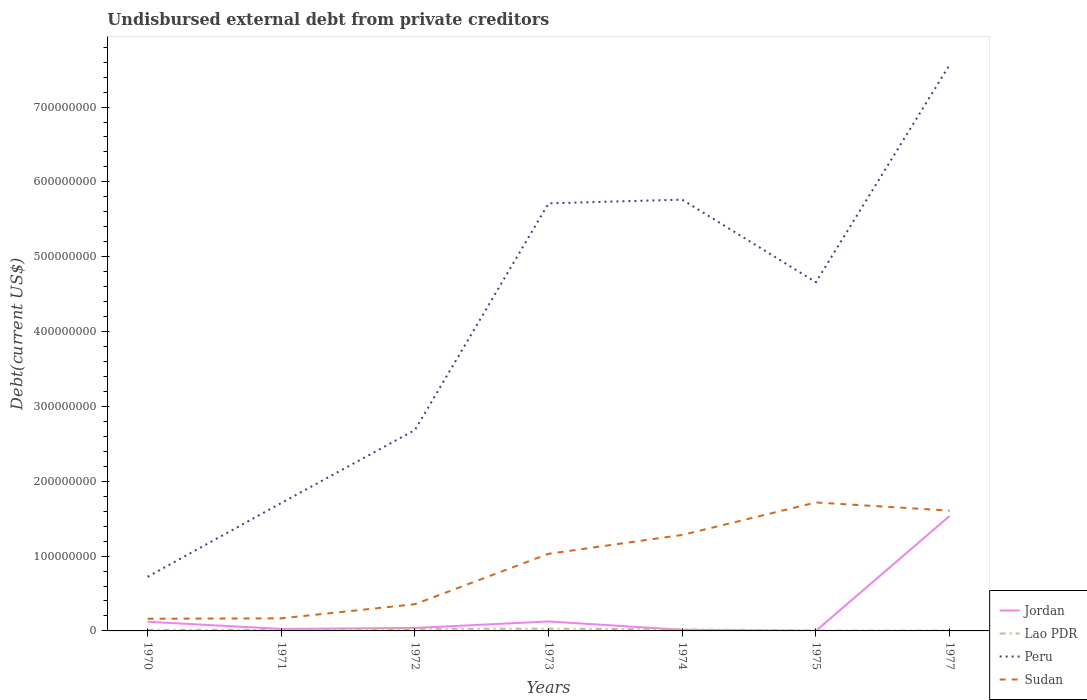How many different coloured lines are there?
Give a very brief answer. 4. Does the line corresponding to Jordan intersect with the line corresponding to Sudan?
Make the answer very short. No. Across all years, what is the maximum total debt in Sudan?
Ensure brevity in your answer.  1.63e+07. In which year was the total debt in Jordan maximum?
Keep it short and to the point. 1975. What is the total total debt in Peru in the graph?
Ensure brevity in your answer.  -6.84e+08. What is the difference between the highest and the second highest total debt in Lao PDR?
Your answer should be very brief. 2.59e+06. How many lines are there?
Offer a very short reply. 4. Where does the legend appear in the graph?
Your answer should be compact. Bottom right. How many legend labels are there?
Your response must be concise. 4. How are the legend labels stacked?
Provide a succinct answer. Vertical. What is the title of the graph?
Offer a very short reply. Undisbursed external debt from private creditors. Does "Japan" appear as one of the legend labels in the graph?
Make the answer very short. No. What is the label or title of the X-axis?
Give a very brief answer. Years. What is the label or title of the Y-axis?
Provide a short and direct response. Debt(current US$). What is the Debt(current US$) of Jordan in 1970?
Offer a terse response. 1.22e+07. What is the Debt(current US$) in Lao PDR in 1970?
Ensure brevity in your answer.  1.40e+06. What is the Debt(current US$) of Peru in 1970?
Keep it short and to the point. 7.23e+07. What is the Debt(current US$) of Sudan in 1970?
Offer a very short reply. 1.63e+07. What is the Debt(current US$) of Jordan in 1971?
Keep it short and to the point. 2.68e+06. What is the Debt(current US$) in Lao PDR in 1971?
Provide a succinct answer. 1.48e+06. What is the Debt(current US$) of Peru in 1971?
Offer a terse response. 1.71e+08. What is the Debt(current US$) of Sudan in 1971?
Offer a terse response. 1.68e+07. What is the Debt(current US$) in Jordan in 1972?
Offer a terse response. 3.98e+06. What is the Debt(current US$) of Lao PDR in 1972?
Provide a succinct answer. 2.75e+06. What is the Debt(current US$) in Peru in 1972?
Offer a terse response. 2.68e+08. What is the Debt(current US$) in Sudan in 1972?
Provide a short and direct response. 3.57e+07. What is the Debt(current US$) of Jordan in 1973?
Ensure brevity in your answer.  1.26e+07. What is the Debt(current US$) in Lao PDR in 1973?
Your answer should be compact. 3.04e+06. What is the Debt(current US$) in Peru in 1973?
Give a very brief answer. 5.71e+08. What is the Debt(current US$) of Sudan in 1973?
Give a very brief answer. 1.03e+08. What is the Debt(current US$) in Jordan in 1974?
Give a very brief answer. 1.51e+06. What is the Debt(current US$) of Lao PDR in 1974?
Your response must be concise. 2.06e+06. What is the Debt(current US$) of Peru in 1974?
Your answer should be very brief. 5.76e+08. What is the Debt(current US$) of Sudan in 1974?
Your response must be concise. 1.28e+08. What is the Debt(current US$) in Jordan in 1975?
Provide a short and direct response. 1.30e+04. What is the Debt(current US$) in Lao PDR in 1975?
Your answer should be compact. 5.19e+05. What is the Debt(current US$) in Peru in 1975?
Your response must be concise. 4.66e+08. What is the Debt(current US$) in Sudan in 1975?
Your response must be concise. 1.72e+08. What is the Debt(current US$) of Jordan in 1977?
Offer a terse response. 1.54e+08. What is the Debt(current US$) in Lao PDR in 1977?
Your answer should be very brief. 4.46e+05. What is the Debt(current US$) of Peru in 1977?
Your response must be concise. 7.56e+08. What is the Debt(current US$) of Sudan in 1977?
Offer a very short reply. 1.61e+08. Across all years, what is the maximum Debt(current US$) of Jordan?
Your answer should be compact. 1.54e+08. Across all years, what is the maximum Debt(current US$) in Lao PDR?
Offer a very short reply. 3.04e+06. Across all years, what is the maximum Debt(current US$) in Peru?
Provide a short and direct response. 7.56e+08. Across all years, what is the maximum Debt(current US$) in Sudan?
Provide a succinct answer. 1.72e+08. Across all years, what is the minimum Debt(current US$) of Jordan?
Provide a succinct answer. 1.30e+04. Across all years, what is the minimum Debt(current US$) in Lao PDR?
Make the answer very short. 4.46e+05. Across all years, what is the minimum Debt(current US$) in Peru?
Your response must be concise. 7.23e+07. Across all years, what is the minimum Debt(current US$) of Sudan?
Provide a short and direct response. 1.63e+07. What is the total Debt(current US$) in Jordan in the graph?
Your answer should be very brief. 1.87e+08. What is the total Debt(current US$) in Lao PDR in the graph?
Your answer should be very brief. 1.17e+07. What is the total Debt(current US$) in Peru in the graph?
Keep it short and to the point. 2.88e+09. What is the total Debt(current US$) in Sudan in the graph?
Your answer should be compact. 6.32e+08. What is the difference between the Debt(current US$) of Jordan in 1970 and that in 1971?
Make the answer very short. 9.56e+06. What is the difference between the Debt(current US$) of Lao PDR in 1970 and that in 1971?
Make the answer very short. -8.90e+04. What is the difference between the Debt(current US$) in Peru in 1970 and that in 1971?
Give a very brief answer. -9.86e+07. What is the difference between the Debt(current US$) in Sudan in 1970 and that in 1971?
Offer a very short reply. -5.22e+05. What is the difference between the Debt(current US$) in Jordan in 1970 and that in 1972?
Your response must be concise. 8.26e+06. What is the difference between the Debt(current US$) in Lao PDR in 1970 and that in 1972?
Ensure brevity in your answer.  -1.35e+06. What is the difference between the Debt(current US$) of Peru in 1970 and that in 1972?
Offer a terse response. -1.96e+08. What is the difference between the Debt(current US$) in Sudan in 1970 and that in 1972?
Make the answer very short. -1.94e+07. What is the difference between the Debt(current US$) of Jordan in 1970 and that in 1973?
Ensure brevity in your answer.  -3.90e+05. What is the difference between the Debt(current US$) of Lao PDR in 1970 and that in 1973?
Provide a short and direct response. -1.64e+06. What is the difference between the Debt(current US$) in Peru in 1970 and that in 1973?
Make the answer very short. -4.99e+08. What is the difference between the Debt(current US$) in Sudan in 1970 and that in 1973?
Keep it short and to the point. -8.68e+07. What is the difference between the Debt(current US$) in Jordan in 1970 and that in 1974?
Offer a terse response. 1.07e+07. What is the difference between the Debt(current US$) of Lao PDR in 1970 and that in 1974?
Your answer should be compact. -6.63e+05. What is the difference between the Debt(current US$) in Peru in 1970 and that in 1974?
Keep it short and to the point. -5.04e+08. What is the difference between the Debt(current US$) of Sudan in 1970 and that in 1974?
Provide a short and direct response. -1.12e+08. What is the difference between the Debt(current US$) in Jordan in 1970 and that in 1975?
Your answer should be compact. 1.22e+07. What is the difference between the Debt(current US$) of Lao PDR in 1970 and that in 1975?
Provide a succinct answer. 8.76e+05. What is the difference between the Debt(current US$) of Peru in 1970 and that in 1975?
Offer a terse response. -3.94e+08. What is the difference between the Debt(current US$) in Sudan in 1970 and that in 1975?
Provide a short and direct response. -1.55e+08. What is the difference between the Debt(current US$) in Jordan in 1970 and that in 1977?
Provide a succinct answer. -1.41e+08. What is the difference between the Debt(current US$) of Lao PDR in 1970 and that in 1977?
Provide a short and direct response. 9.49e+05. What is the difference between the Debt(current US$) in Peru in 1970 and that in 1977?
Ensure brevity in your answer.  -6.84e+08. What is the difference between the Debt(current US$) of Sudan in 1970 and that in 1977?
Your answer should be very brief. -1.44e+08. What is the difference between the Debt(current US$) of Jordan in 1971 and that in 1972?
Offer a terse response. -1.30e+06. What is the difference between the Debt(current US$) of Lao PDR in 1971 and that in 1972?
Ensure brevity in your answer.  -1.26e+06. What is the difference between the Debt(current US$) in Peru in 1971 and that in 1972?
Give a very brief answer. -9.75e+07. What is the difference between the Debt(current US$) of Sudan in 1971 and that in 1972?
Ensure brevity in your answer.  -1.89e+07. What is the difference between the Debt(current US$) in Jordan in 1971 and that in 1973?
Your response must be concise. -9.96e+06. What is the difference between the Debt(current US$) in Lao PDR in 1971 and that in 1973?
Ensure brevity in your answer.  -1.56e+06. What is the difference between the Debt(current US$) in Peru in 1971 and that in 1973?
Your response must be concise. -4.00e+08. What is the difference between the Debt(current US$) of Sudan in 1971 and that in 1973?
Ensure brevity in your answer.  -8.63e+07. What is the difference between the Debt(current US$) in Jordan in 1971 and that in 1974?
Provide a succinct answer. 1.17e+06. What is the difference between the Debt(current US$) in Lao PDR in 1971 and that in 1974?
Your answer should be very brief. -5.74e+05. What is the difference between the Debt(current US$) in Peru in 1971 and that in 1974?
Give a very brief answer. -4.05e+08. What is the difference between the Debt(current US$) in Sudan in 1971 and that in 1974?
Offer a very short reply. -1.11e+08. What is the difference between the Debt(current US$) in Jordan in 1971 and that in 1975?
Ensure brevity in your answer.  2.67e+06. What is the difference between the Debt(current US$) of Lao PDR in 1971 and that in 1975?
Your answer should be very brief. 9.65e+05. What is the difference between the Debt(current US$) of Peru in 1971 and that in 1975?
Your answer should be very brief. -2.95e+08. What is the difference between the Debt(current US$) in Sudan in 1971 and that in 1975?
Provide a short and direct response. -1.55e+08. What is the difference between the Debt(current US$) of Jordan in 1971 and that in 1977?
Ensure brevity in your answer.  -1.51e+08. What is the difference between the Debt(current US$) of Lao PDR in 1971 and that in 1977?
Offer a very short reply. 1.04e+06. What is the difference between the Debt(current US$) of Peru in 1971 and that in 1977?
Provide a short and direct response. -5.85e+08. What is the difference between the Debt(current US$) in Sudan in 1971 and that in 1977?
Make the answer very short. -1.44e+08. What is the difference between the Debt(current US$) in Jordan in 1972 and that in 1973?
Make the answer very short. -8.65e+06. What is the difference between the Debt(current US$) of Lao PDR in 1972 and that in 1973?
Your answer should be very brief. -2.92e+05. What is the difference between the Debt(current US$) of Peru in 1972 and that in 1973?
Make the answer very short. -3.03e+08. What is the difference between the Debt(current US$) in Sudan in 1972 and that in 1973?
Your answer should be very brief. -6.73e+07. What is the difference between the Debt(current US$) of Jordan in 1972 and that in 1974?
Make the answer very short. 2.47e+06. What is the difference between the Debt(current US$) in Lao PDR in 1972 and that in 1974?
Your response must be concise. 6.89e+05. What is the difference between the Debt(current US$) of Peru in 1972 and that in 1974?
Give a very brief answer. -3.08e+08. What is the difference between the Debt(current US$) in Sudan in 1972 and that in 1974?
Make the answer very short. -9.26e+07. What is the difference between the Debt(current US$) in Jordan in 1972 and that in 1975?
Give a very brief answer. 3.97e+06. What is the difference between the Debt(current US$) in Lao PDR in 1972 and that in 1975?
Provide a short and direct response. 2.23e+06. What is the difference between the Debt(current US$) in Peru in 1972 and that in 1975?
Give a very brief answer. -1.97e+08. What is the difference between the Debt(current US$) in Sudan in 1972 and that in 1975?
Keep it short and to the point. -1.36e+08. What is the difference between the Debt(current US$) of Jordan in 1972 and that in 1977?
Make the answer very short. -1.50e+08. What is the difference between the Debt(current US$) of Lao PDR in 1972 and that in 1977?
Offer a very short reply. 2.30e+06. What is the difference between the Debt(current US$) in Peru in 1972 and that in 1977?
Your answer should be very brief. -4.88e+08. What is the difference between the Debt(current US$) in Sudan in 1972 and that in 1977?
Your answer should be compact. -1.25e+08. What is the difference between the Debt(current US$) in Jordan in 1973 and that in 1974?
Give a very brief answer. 1.11e+07. What is the difference between the Debt(current US$) of Lao PDR in 1973 and that in 1974?
Offer a very short reply. 9.81e+05. What is the difference between the Debt(current US$) of Peru in 1973 and that in 1974?
Offer a very short reply. -4.98e+06. What is the difference between the Debt(current US$) in Sudan in 1973 and that in 1974?
Offer a terse response. -2.52e+07. What is the difference between the Debt(current US$) of Jordan in 1973 and that in 1975?
Make the answer very short. 1.26e+07. What is the difference between the Debt(current US$) of Lao PDR in 1973 and that in 1975?
Your answer should be very brief. 2.52e+06. What is the difference between the Debt(current US$) in Peru in 1973 and that in 1975?
Give a very brief answer. 1.05e+08. What is the difference between the Debt(current US$) of Sudan in 1973 and that in 1975?
Your response must be concise. -6.86e+07. What is the difference between the Debt(current US$) of Jordan in 1973 and that in 1977?
Your answer should be very brief. -1.41e+08. What is the difference between the Debt(current US$) in Lao PDR in 1973 and that in 1977?
Give a very brief answer. 2.59e+06. What is the difference between the Debt(current US$) of Peru in 1973 and that in 1977?
Make the answer very short. -1.85e+08. What is the difference between the Debt(current US$) of Sudan in 1973 and that in 1977?
Offer a terse response. -5.77e+07. What is the difference between the Debt(current US$) of Jordan in 1974 and that in 1975?
Your response must be concise. 1.50e+06. What is the difference between the Debt(current US$) in Lao PDR in 1974 and that in 1975?
Make the answer very short. 1.54e+06. What is the difference between the Debt(current US$) of Peru in 1974 and that in 1975?
Your answer should be very brief. 1.10e+08. What is the difference between the Debt(current US$) in Sudan in 1974 and that in 1975?
Make the answer very short. -4.34e+07. What is the difference between the Debt(current US$) of Jordan in 1974 and that in 1977?
Offer a very short reply. -1.52e+08. What is the difference between the Debt(current US$) of Lao PDR in 1974 and that in 1977?
Provide a succinct answer. 1.61e+06. What is the difference between the Debt(current US$) in Peru in 1974 and that in 1977?
Make the answer very short. -1.80e+08. What is the difference between the Debt(current US$) of Sudan in 1974 and that in 1977?
Give a very brief answer. -3.25e+07. What is the difference between the Debt(current US$) of Jordan in 1975 and that in 1977?
Offer a very short reply. -1.54e+08. What is the difference between the Debt(current US$) of Lao PDR in 1975 and that in 1977?
Your answer should be compact. 7.30e+04. What is the difference between the Debt(current US$) in Peru in 1975 and that in 1977?
Provide a short and direct response. -2.90e+08. What is the difference between the Debt(current US$) of Sudan in 1975 and that in 1977?
Make the answer very short. 1.09e+07. What is the difference between the Debt(current US$) of Jordan in 1970 and the Debt(current US$) of Lao PDR in 1971?
Make the answer very short. 1.08e+07. What is the difference between the Debt(current US$) in Jordan in 1970 and the Debt(current US$) in Peru in 1971?
Offer a very short reply. -1.59e+08. What is the difference between the Debt(current US$) in Jordan in 1970 and the Debt(current US$) in Sudan in 1971?
Your answer should be compact. -4.55e+06. What is the difference between the Debt(current US$) of Lao PDR in 1970 and the Debt(current US$) of Peru in 1971?
Provide a short and direct response. -1.70e+08. What is the difference between the Debt(current US$) of Lao PDR in 1970 and the Debt(current US$) of Sudan in 1971?
Give a very brief answer. -1.54e+07. What is the difference between the Debt(current US$) in Peru in 1970 and the Debt(current US$) in Sudan in 1971?
Provide a short and direct response. 5.55e+07. What is the difference between the Debt(current US$) in Jordan in 1970 and the Debt(current US$) in Lao PDR in 1972?
Provide a succinct answer. 9.50e+06. What is the difference between the Debt(current US$) in Jordan in 1970 and the Debt(current US$) in Peru in 1972?
Offer a very short reply. -2.56e+08. What is the difference between the Debt(current US$) of Jordan in 1970 and the Debt(current US$) of Sudan in 1972?
Offer a very short reply. -2.35e+07. What is the difference between the Debt(current US$) in Lao PDR in 1970 and the Debt(current US$) in Peru in 1972?
Keep it short and to the point. -2.67e+08. What is the difference between the Debt(current US$) of Lao PDR in 1970 and the Debt(current US$) of Sudan in 1972?
Provide a short and direct response. -3.43e+07. What is the difference between the Debt(current US$) in Peru in 1970 and the Debt(current US$) in Sudan in 1972?
Your answer should be compact. 3.66e+07. What is the difference between the Debt(current US$) in Jordan in 1970 and the Debt(current US$) in Lao PDR in 1973?
Keep it short and to the point. 9.21e+06. What is the difference between the Debt(current US$) of Jordan in 1970 and the Debt(current US$) of Peru in 1973?
Keep it short and to the point. -5.59e+08. What is the difference between the Debt(current US$) in Jordan in 1970 and the Debt(current US$) in Sudan in 1973?
Offer a terse response. -9.08e+07. What is the difference between the Debt(current US$) in Lao PDR in 1970 and the Debt(current US$) in Peru in 1973?
Your answer should be very brief. -5.70e+08. What is the difference between the Debt(current US$) of Lao PDR in 1970 and the Debt(current US$) of Sudan in 1973?
Keep it short and to the point. -1.02e+08. What is the difference between the Debt(current US$) in Peru in 1970 and the Debt(current US$) in Sudan in 1973?
Your answer should be compact. -3.07e+07. What is the difference between the Debt(current US$) of Jordan in 1970 and the Debt(current US$) of Lao PDR in 1974?
Ensure brevity in your answer.  1.02e+07. What is the difference between the Debt(current US$) of Jordan in 1970 and the Debt(current US$) of Peru in 1974?
Your answer should be compact. -5.64e+08. What is the difference between the Debt(current US$) of Jordan in 1970 and the Debt(current US$) of Sudan in 1974?
Keep it short and to the point. -1.16e+08. What is the difference between the Debt(current US$) of Lao PDR in 1970 and the Debt(current US$) of Peru in 1974?
Make the answer very short. -5.75e+08. What is the difference between the Debt(current US$) of Lao PDR in 1970 and the Debt(current US$) of Sudan in 1974?
Ensure brevity in your answer.  -1.27e+08. What is the difference between the Debt(current US$) in Peru in 1970 and the Debt(current US$) in Sudan in 1974?
Give a very brief answer. -5.60e+07. What is the difference between the Debt(current US$) of Jordan in 1970 and the Debt(current US$) of Lao PDR in 1975?
Offer a very short reply. 1.17e+07. What is the difference between the Debt(current US$) in Jordan in 1970 and the Debt(current US$) in Peru in 1975?
Keep it short and to the point. -4.54e+08. What is the difference between the Debt(current US$) in Jordan in 1970 and the Debt(current US$) in Sudan in 1975?
Give a very brief answer. -1.59e+08. What is the difference between the Debt(current US$) in Lao PDR in 1970 and the Debt(current US$) in Peru in 1975?
Your answer should be very brief. -4.65e+08. What is the difference between the Debt(current US$) of Lao PDR in 1970 and the Debt(current US$) of Sudan in 1975?
Your answer should be very brief. -1.70e+08. What is the difference between the Debt(current US$) of Peru in 1970 and the Debt(current US$) of Sudan in 1975?
Keep it short and to the point. -9.94e+07. What is the difference between the Debt(current US$) of Jordan in 1970 and the Debt(current US$) of Lao PDR in 1977?
Provide a succinct answer. 1.18e+07. What is the difference between the Debt(current US$) in Jordan in 1970 and the Debt(current US$) in Peru in 1977?
Your answer should be compact. -7.44e+08. What is the difference between the Debt(current US$) of Jordan in 1970 and the Debt(current US$) of Sudan in 1977?
Your answer should be compact. -1.48e+08. What is the difference between the Debt(current US$) in Lao PDR in 1970 and the Debt(current US$) in Peru in 1977?
Offer a terse response. -7.55e+08. What is the difference between the Debt(current US$) of Lao PDR in 1970 and the Debt(current US$) of Sudan in 1977?
Offer a terse response. -1.59e+08. What is the difference between the Debt(current US$) of Peru in 1970 and the Debt(current US$) of Sudan in 1977?
Your response must be concise. -8.84e+07. What is the difference between the Debt(current US$) of Jordan in 1971 and the Debt(current US$) of Lao PDR in 1972?
Your answer should be compact. -6.50e+04. What is the difference between the Debt(current US$) in Jordan in 1971 and the Debt(current US$) in Peru in 1972?
Your answer should be very brief. -2.66e+08. What is the difference between the Debt(current US$) of Jordan in 1971 and the Debt(current US$) of Sudan in 1972?
Provide a short and direct response. -3.30e+07. What is the difference between the Debt(current US$) in Lao PDR in 1971 and the Debt(current US$) in Peru in 1972?
Your answer should be very brief. -2.67e+08. What is the difference between the Debt(current US$) in Lao PDR in 1971 and the Debt(current US$) in Sudan in 1972?
Give a very brief answer. -3.42e+07. What is the difference between the Debt(current US$) in Peru in 1971 and the Debt(current US$) in Sudan in 1972?
Make the answer very short. 1.35e+08. What is the difference between the Debt(current US$) in Jordan in 1971 and the Debt(current US$) in Lao PDR in 1973?
Provide a short and direct response. -3.57e+05. What is the difference between the Debt(current US$) of Jordan in 1971 and the Debt(current US$) of Peru in 1973?
Your answer should be compact. -5.69e+08. What is the difference between the Debt(current US$) of Jordan in 1971 and the Debt(current US$) of Sudan in 1973?
Your answer should be compact. -1.00e+08. What is the difference between the Debt(current US$) in Lao PDR in 1971 and the Debt(current US$) in Peru in 1973?
Offer a terse response. -5.70e+08. What is the difference between the Debt(current US$) of Lao PDR in 1971 and the Debt(current US$) of Sudan in 1973?
Your response must be concise. -1.02e+08. What is the difference between the Debt(current US$) in Peru in 1971 and the Debt(current US$) in Sudan in 1973?
Provide a short and direct response. 6.79e+07. What is the difference between the Debt(current US$) in Jordan in 1971 and the Debt(current US$) in Lao PDR in 1974?
Your response must be concise. 6.24e+05. What is the difference between the Debt(current US$) of Jordan in 1971 and the Debt(current US$) of Peru in 1974?
Keep it short and to the point. -5.74e+08. What is the difference between the Debt(current US$) in Jordan in 1971 and the Debt(current US$) in Sudan in 1974?
Your answer should be compact. -1.26e+08. What is the difference between the Debt(current US$) in Lao PDR in 1971 and the Debt(current US$) in Peru in 1974?
Offer a very short reply. -5.75e+08. What is the difference between the Debt(current US$) of Lao PDR in 1971 and the Debt(current US$) of Sudan in 1974?
Your response must be concise. -1.27e+08. What is the difference between the Debt(current US$) in Peru in 1971 and the Debt(current US$) in Sudan in 1974?
Your answer should be compact. 4.27e+07. What is the difference between the Debt(current US$) of Jordan in 1971 and the Debt(current US$) of Lao PDR in 1975?
Offer a terse response. 2.16e+06. What is the difference between the Debt(current US$) in Jordan in 1971 and the Debt(current US$) in Peru in 1975?
Keep it short and to the point. -4.63e+08. What is the difference between the Debt(current US$) in Jordan in 1971 and the Debt(current US$) in Sudan in 1975?
Provide a succinct answer. -1.69e+08. What is the difference between the Debt(current US$) in Lao PDR in 1971 and the Debt(current US$) in Peru in 1975?
Your answer should be compact. -4.64e+08. What is the difference between the Debt(current US$) in Lao PDR in 1971 and the Debt(current US$) in Sudan in 1975?
Offer a terse response. -1.70e+08. What is the difference between the Debt(current US$) of Peru in 1971 and the Debt(current US$) of Sudan in 1975?
Make the answer very short. -7.37e+05. What is the difference between the Debt(current US$) of Jordan in 1971 and the Debt(current US$) of Lao PDR in 1977?
Your answer should be compact. 2.24e+06. What is the difference between the Debt(current US$) in Jordan in 1971 and the Debt(current US$) in Peru in 1977?
Make the answer very short. -7.54e+08. What is the difference between the Debt(current US$) of Jordan in 1971 and the Debt(current US$) of Sudan in 1977?
Provide a succinct answer. -1.58e+08. What is the difference between the Debt(current US$) in Lao PDR in 1971 and the Debt(current US$) in Peru in 1977?
Make the answer very short. -7.55e+08. What is the difference between the Debt(current US$) of Lao PDR in 1971 and the Debt(current US$) of Sudan in 1977?
Offer a very short reply. -1.59e+08. What is the difference between the Debt(current US$) in Peru in 1971 and the Debt(current US$) in Sudan in 1977?
Your answer should be very brief. 1.02e+07. What is the difference between the Debt(current US$) in Jordan in 1972 and the Debt(current US$) in Lao PDR in 1973?
Your response must be concise. 9.44e+05. What is the difference between the Debt(current US$) in Jordan in 1972 and the Debt(current US$) in Peru in 1973?
Offer a terse response. -5.67e+08. What is the difference between the Debt(current US$) of Jordan in 1972 and the Debt(current US$) of Sudan in 1973?
Provide a succinct answer. -9.91e+07. What is the difference between the Debt(current US$) in Lao PDR in 1972 and the Debt(current US$) in Peru in 1973?
Make the answer very short. -5.69e+08. What is the difference between the Debt(current US$) of Lao PDR in 1972 and the Debt(current US$) of Sudan in 1973?
Your answer should be compact. -1.00e+08. What is the difference between the Debt(current US$) in Peru in 1972 and the Debt(current US$) in Sudan in 1973?
Your answer should be compact. 1.65e+08. What is the difference between the Debt(current US$) of Jordan in 1972 and the Debt(current US$) of Lao PDR in 1974?
Your answer should be compact. 1.92e+06. What is the difference between the Debt(current US$) in Jordan in 1972 and the Debt(current US$) in Peru in 1974?
Make the answer very short. -5.72e+08. What is the difference between the Debt(current US$) of Jordan in 1972 and the Debt(current US$) of Sudan in 1974?
Keep it short and to the point. -1.24e+08. What is the difference between the Debt(current US$) in Lao PDR in 1972 and the Debt(current US$) in Peru in 1974?
Ensure brevity in your answer.  -5.74e+08. What is the difference between the Debt(current US$) in Lao PDR in 1972 and the Debt(current US$) in Sudan in 1974?
Provide a short and direct response. -1.26e+08. What is the difference between the Debt(current US$) in Peru in 1972 and the Debt(current US$) in Sudan in 1974?
Make the answer very short. 1.40e+08. What is the difference between the Debt(current US$) in Jordan in 1972 and the Debt(current US$) in Lao PDR in 1975?
Offer a very short reply. 3.46e+06. What is the difference between the Debt(current US$) of Jordan in 1972 and the Debt(current US$) of Peru in 1975?
Your answer should be very brief. -4.62e+08. What is the difference between the Debt(current US$) in Jordan in 1972 and the Debt(current US$) in Sudan in 1975?
Keep it short and to the point. -1.68e+08. What is the difference between the Debt(current US$) in Lao PDR in 1972 and the Debt(current US$) in Peru in 1975?
Ensure brevity in your answer.  -4.63e+08. What is the difference between the Debt(current US$) in Lao PDR in 1972 and the Debt(current US$) in Sudan in 1975?
Offer a very short reply. -1.69e+08. What is the difference between the Debt(current US$) in Peru in 1972 and the Debt(current US$) in Sudan in 1975?
Give a very brief answer. 9.68e+07. What is the difference between the Debt(current US$) in Jordan in 1972 and the Debt(current US$) in Lao PDR in 1977?
Offer a terse response. 3.54e+06. What is the difference between the Debt(current US$) of Jordan in 1972 and the Debt(current US$) of Peru in 1977?
Make the answer very short. -7.52e+08. What is the difference between the Debt(current US$) of Jordan in 1972 and the Debt(current US$) of Sudan in 1977?
Your answer should be compact. -1.57e+08. What is the difference between the Debt(current US$) in Lao PDR in 1972 and the Debt(current US$) in Peru in 1977?
Your answer should be compact. -7.54e+08. What is the difference between the Debt(current US$) in Lao PDR in 1972 and the Debt(current US$) in Sudan in 1977?
Provide a short and direct response. -1.58e+08. What is the difference between the Debt(current US$) in Peru in 1972 and the Debt(current US$) in Sudan in 1977?
Ensure brevity in your answer.  1.08e+08. What is the difference between the Debt(current US$) in Jordan in 1973 and the Debt(current US$) in Lao PDR in 1974?
Make the answer very short. 1.06e+07. What is the difference between the Debt(current US$) in Jordan in 1973 and the Debt(current US$) in Peru in 1974?
Give a very brief answer. -5.64e+08. What is the difference between the Debt(current US$) in Jordan in 1973 and the Debt(current US$) in Sudan in 1974?
Your response must be concise. -1.16e+08. What is the difference between the Debt(current US$) of Lao PDR in 1973 and the Debt(current US$) of Peru in 1974?
Provide a short and direct response. -5.73e+08. What is the difference between the Debt(current US$) in Lao PDR in 1973 and the Debt(current US$) in Sudan in 1974?
Offer a terse response. -1.25e+08. What is the difference between the Debt(current US$) of Peru in 1973 and the Debt(current US$) of Sudan in 1974?
Offer a terse response. 4.43e+08. What is the difference between the Debt(current US$) of Jordan in 1973 and the Debt(current US$) of Lao PDR in 1975?
Give a very brief answer. 1.21e+07. What is the difference between the Debt(current US$) in Jordan in 1973 and the Debt(current US$) in Peru in 1975?
Give a very brief answer. -4.53e+08. What is the difference between the Debt(current US$) of Jordan in 1973 and the Debt(current US$) of Sudan in 1975?
Provide a short and direct response. -1.59e+08. What is the difference between the Debt(current US$) in Lao PDR in 1973 and the Debt(current US$) in Peru in 1975?
Provide a short and direct response. -4.63e+08. What is the difference between the Debt(current US$) of Lao PDR in 1973 and the Debt(current US$) of Sudan in 1975?
Offer a terse response. -1.69e+08. What is the difference between the Debt(current US$) of Peru in 1973 and the Debt(current US$) of Sudan in 1975?
Offer a very short reply. 4.00e+08. What is the difference between the Debt(current US$) in Jordan in 1973 and the Debt(current US$) in Lao PDR in 1977?
Provide a succinct answer. 1.22e+07. What is the difference between the Debt(current US$) in Jordan in 1973 and the Debt(current US$) in Peru in 1977?
Give a very brief answer. -7.44e+08. What is the difference between the Debt(current US$) of Jordan in 1973 and the Debt(current US$) of Sudan in 1977?
Give a very brief answer. -1.48e+08. What is the difference between the Debt(current US$) in Lao PDR in 1973 and the Debt(current US$) in Peru in 1977?
Ensure brevity in your answer.  -7.53e+08. What is the difference between the Debt(current US$) of Lao PDR in 1973 and the Debt(current US$) of Sudan in 1977?
Offer a very short reply. -1.58e+08. What is the difference between the Debt(current US$) in Peru in 1973 and the Debt(current US$) in Sudan in 1977?
Ensure brevity in your answer.  4.11e+08. What is the difference between the Debt(current US$) of Jordan in 1974 and the Debt(current US$) of Lao PDR in 1975?
Provide a succinct answer. 9.92e+05. What is the difference between the Debt(current US$) in Jordan in 1974 and the Debt(current US$) in Peru in 1975?
Provide a succinct answer. -4.64e+08. What is the difference between the Debt(current US$) in Jordan in 1974 and the Debt(current US$) in Sudan in 1975?
Provide a short and direct response. -1.70e+08. What is the difference between the Debt(current US$) in Lao PDR in 1974 and the Debt(current US$) in Peru in 1975?
Give a very brief answer. -4.64e+08. What is the difference between the Debt(current US$) in Lao PDR in 1974 and the Debt(current US$) in Sudan in 1975?
Offer a very short reply. -1.70e+08. What is the difference between the Debt(current US$) in Peru in 1974 and the Debt(current US$) in Sudan in 1975?
Your response must be concise. 4.05e+08. What is the difference between the Debt(current US$) in Jordan in 1974 and the Debt(current US$) in Lao PDR in 1977?
Make the answer very short. 1.06e+06. What is the difference between the Debt(current US$) of Jordan in 1974 and the Debt(current US$) of Peru in 1977?
Make the answer very short. -7.55e+08. What is the difference between the Debt(current US$) of Jordan in 1974 and the Debt(current US$) of Sudan in 1977?
Your answer should be very brief. -1.59e+08. What is the difference between the Debt(current US$) in Lao PDR in 1974 and the Debt(current US$) in Peru in 1977?
Offer a very short reply. -7.54e+08. What is the difference between the Debt(current US$) of Lao PDR in 1974 and the Debt(current US$) of Sudan in 1977?
Provide a short and direct response. -1.59e+08. What is the difference between the Debt(current US$) in Peru in 1974 and the Debt(current US$) in Sudan in 1977?
Make the answer very short. 4.16e+08. What is the difference between the Debt(current US$) of Jordan in 1975 and the Debt(current US$) of Lao PDR in 1977?
Ensure brevity in your answer.  -4.33e+05. What is the difference between the Debt(current US$) in Jordan in 1975 and the Debt(current US$) in Peru in 1977?
Give a very brief answer. -7.56e+08. What is the difference between the Debt(current US$) in Jordan in 1975 and the Debt(current US$) in Sudan in 1977?
Provide a short and direct response. -1.61e+08. What is the difference between the Debt(current US$) of Lao PDR in 1975 and the Debt(current US$) of Peru in 1977?
Provide a succinct answer. -7.56e+08. What is the difference between the Debt(current US$) in Lao PDR in 1975 and the Debt(current US$) in Sudan in 1977?
Your answer should be very brief. -1.60e+08. What is the difference between the Debt(current US$) in Peru in 1975 and the Debt(current US$) in Sudan in 1977?
Give a very brief answer. 3.05e+08. What is the average Debt(current US$) of Jordan per year?
Provide a succinct answer. 2.67e+07. What is the average Debt(current US$) of Lao PDR per year?
Offer a terse response. 1.67e+06. What is the average Debt(current US$) of Peru per year?
Make the answer very short. 4.12e+08. What is the average Debt(current US$) in Sudan per year?
Your answer should be very brief. 9.04e+07. In the year 1970, what is the difference between the Debt(current US$) of Jordan and Debt(current US$) of Lao PDR?
Offer a terse response. 1.09e+07. In the year 1970, what is the difference between the Debt(current US$) of Jordan and Debt(current US$) of Peru?
Your answer should be very brief. -6.01e+07. In the year 1970, what is the difference between the Debt(current US$) of Jordan and Debt(current US$) of Sudan?
Offer a terse response. -4.02e+06. In the year 1970, what is the difference between the Debt(current US$) of Lao PDR and Debt(current US$) of Peru?
Provide a short and direct response. -7.09e+07. In the year 1970, what is the difference between the Debt(current US$) in Lao PDR and Debt(current US$) in Sudan?
Offer a terse response. -1.49e+07. In the year 1970, what is the difference between the Debt(current US$) of Peru and Debt(current US$) of Sudan?
Keep it short and to the point. 5.60e+07. In the year 1971, what is the difference between the Debt(current US$) of Jordan and Debt(current US$) of Lao PDR?
Your answer should be very brief. 1.20e+06. In the year 1971, what is the difference between the Debt(current US$) of Jordan and Debt(current US$) of Peru?
Your response must be concise. -1.68e+08. In the year 1971, what is the difference between the Debt(current US$) in Jordan and Debt(current US$) in Sudan?
Make the answer very short. -1.41e+07. In the year 1971, what is the difference between the Debt(current US$) in Lao PDR and Debt(current US$) in Peru?
Ensure brevity in your answer.  -1.69e+08. In the year 1971, what is the difference between the Debt(current US$) in Lao PDR and Debt(current US$) in Sudan?
Provide a short and direct response. -1.53e+07. In the year 1971, what is the difference between the Debt(current US$) of Peru and Debt(current US$) of Sudan?
Provide a short and direct response. 1.54e+08. In the year 1972, what is the difference between the Debt(current US$) in Jordan and Debt(current US$) in Lao PDR?
Make the answer very short. 1.24e+06. In the year 1972, what is the difference between the Debt(current US$) in Jordan and Debt(current US$) in Peru?
Your answer should be very brief. -2.64e+08. In the year 1972, what is the difference between the Debt(current US$) in Jordan and Debt(current US$) in Sudan?
Ensure brevity in your answer.  -3.17e+07. In the year 1972, what is the difference between the Debt(current US$) in Lao PDR and Debt(current US$) in Peru?
Your answer should be very brief. -2.66e+08. In the year 1972, what is the difference between the Debt(current US$) of Lao PDR and Debt(current US$) of Sudan?
Provide a short and direct response. -3.30e+07. In the year 1972, what is the difference between the Debt(current US$) of Peru and Debt(current US$) of Sudan?
Provide a short and direct response. 2.33e+08. In the year 1973, what is the difference between the Debt(current US$) of Jordan and Debt(current US$) of Lao PDR?
Provide a succinct answer. 9.60e+06. In the year 1973, what is the difference between the Debt(current US$) in Jordan and Debt(current US$) in Peru?
Provide a short and direct response. -5.59e+08. In the year 1973, what is the difference between the Debt(current US$) in Jordan and Debt(current US$) in Sudan?
Your answer should be compact. -9.04e+07. In the year 1973, what is the difference between the Debt(current US$) in Lao PDR and Debt(current US$) in Peru?
Offer a terse response. -5.68e+08. In the year 1973, what is the difference between the Debt(current US$) of Lao PDR and Debt(current US$) of Sudan?
Provide a succinct answer. -1.00e+08. In the year 1973, what is the difference between the Debt(current US$) in Peru and Debt(current US$) in Sudan?
Your answer should be very brief. 4.68e+08. In the year 1974, what is the difference between the Debt(current US$) in Jordan and Debt(current US$) in Lao PDR?
Offer a very short reply. -5.47e+05. In the year 1974, what is the difference between the Debt(current US$) of Jordan and Debt(current US$) of Peru?
Your answer should be compact. -5.75e+08. In the year 1974, what is the difference between the Debt(current US$) in Jordan and Debt(current US$) in Sudan?
Provide a succinct answer. -1.27e+08. In the year 1974, what is the difference between the Debt(current US$) of Lao PDR and Debt(current US$) of Peru?
Give a very brief answer. -5.74e+08. In the year 1974, what is the difference between the Debt(current US$) in Lao PDR and Debt(current US$) in Sudan?
Offer a terse response. -1.26e+08. In the year 1974, what is the difference between the Debt(current US$) in Peru and Debt(current US$) in Sudan?
Make the answer very short. 4.48e+08. In the year 1975, what is the difference between the Debt(current US$) of Jordan and Debt(current US$) of Lao PDR?
Make the answer very short. -5.06e+05. In the year 1975, what is the difference between the Debt(current US$) in Jordan and Debt(current US$) in Peru?
Your answer should be very brief. -4.66e+08. In the year 1975, what is the difference between the Debt(current US$) of Jordan and Debt(current US$) of Sudan?
Your response must be concise. -1.72e+08. In the year 1975, what is the difference between the Debt(current US$) in Lao PDR and Debt(current US$) in Peru?
Offer a very short reply. -4.65e+08. In the year 1975, what is the difference between the Debt(current US$) in Lao PDR and Debt(current US$) in Sudan?
Offer a very short reply. -1.71e+08. In the year 1975, what is the difference between the Debt(current US$) of Peru and Debt(current US$) of Sudan?
Make the answer very short. 2.94e+08. In the year 1977, what is the difference between the Debt(current US$) in Jordan and Debt(current US$) in Lao PDR?
Give a very brief answer. 1.53e+08. In the year 1977, what is the difference between the Debt(current US$) of Jordan and Debt(current US$) of Peru?
Provide a succinct answer. -6.03e+08. In the year 1977, what is the difference between the Debt(current US$) in Jordan and Debt(current US$) in Sudan?
Ensure brevity in your answer.  -7.17e+06. In the year 1977, what is the difference between the Debt(current US$) in Lao PDR and Debt(current US$) in Peru?
Make the answer very short. -7.56e+08. In the year 1977, what is the difference between the Debt(current US$) in Lao PDR and Debt(current US$) in Sudan?
Keep it short and to the point. -1.60e+08. In the year 1977, what is the difference between the Debt(current US$) in Peru and Debt(current US$) in Sudan?
Provide a succinct answer. 5.96e+08. What is the ratio of the Debt(current US$) of Jordan in 1970 to that in 1971?
Ensure brevity in your answer.  4.57. What is the ratio of the Debt(current US$) of Lao PDR in 1970 to that in 1971?
Provide a short and direct response. 0.94. What is the ratio of the Debt(current US$) in Peru in 1970 to that in 1971?
Your answer should be compact. 0.42. What is the ratio of the Debt(current US$) in Sudan in 1970 to that in 1971?
Your answer should be very brief. 0.97. What is the ratio of the Debt(current US$) in Jordan in 1970 to that in 1972?
Your response must be concise. 3.07. What is the ratio of the Debt(current US$) of Lao PDR in 1970 to that in 1972?
Your answer should be compact. 0.51. What is the ratio of the Debt(current US$) in Peru in 1970 to that in 1972?
Your response must be concise. 0.27. What is the ratio of the Debt(current US$) of Sudan in 1970 to that in 1972?
Your response must be concise. 0.46. What is the ratio of the Debt(current US$) of Jordan in 1970 to that in 1973?
Keep it short and to the point. 0.97. What is the ratio of the Debt(current US$) of Lao PDR in 1970 to that in 1973?
Make the answer very short. 0.46. What is the ratio of the Debt(current US$) of Peru in 1970 to that in 1973?
Give a very brief answer. 0.13. What is the ratio of the Debt(current US$) in Sudan in 1970 to that in 1973?
Provide a short and direct response. 0.16. What is the ratio of the Debt(current US$) in Jordan in 1970 to that in 1974?
Your response must be concise. 8.11. What is the ratio of the Debt(current US$) of Lao PDR in 1970 to that in 1974?
Ensure brevity in your answer.  0.68. What is the ratio of the Debt(current US$) in Peru in 1970 to that in 1974?
Your answer should be compact. 0.13. What is the ratio of the Debt(current US$) of Sudan in 1970 to that in 1974?
Provide a short and direct response. 0.13. What is the ratio of the Debt(current US$) of Jordan in 1970 to that in 1975?
Give a very brief answer. 942.08. What is the ratio of the Debt(current US$) in Lao PDR in 1970 to that in 1975?
Keep it short and to the point. 2.69. What is the ratio of the Debt(current US$) in Peru in 1970 to that in 1975?
Make the answer very short. 0.16. What is the ratio of the Debt(current US$) in Sudan in 1970 to that in 1975?
Provide a succinct answer. 0.09. What is the ratio of the Debt(current US$) of Jordan in 1970 to that in 1977?
Make the answer very short. 0.08. What is the ratio of the Debt(current US$) of Lao PDR in 1970 to that in 1977?
Give a very brief answer. 3.13. What is the ratio of the Debt(current US$) of Peru in 1970 to that in 1977?
Give a very brief answer. 0.1. What is the ratio of the Debt(current US$) in Sudan in 1970 to that in 1977?
Offer a very short reply. 0.1. What is the ratio of the Debt(current US$) of Jordan in 1971 to that in 1972?
Ensure brevity in your answer.  0.67. What is the ratio of the Debt(current US$) in Lao PDR in 1971 to that in 1972?
Your answer should be very brief. 0.54. What is the ratio of the Debt(current US$) of Peru in 1971 to that in 1972?
Ensure brevity in your answer.  0.64. What is the ratio of the Debt(current US$) of Sudan in 1971 to that in 1972?
Give a very brief answer. 0.47. What is the ratio of the Debt(current US$) in Jordan in 1971 to that in 1973?
Offer a terse response. 0.21. What is the ratio of the Debt(current US$) of Lao PDR in 1971 to that in 1973?
Your answer should be compact. 0.49. What is the ratio of the Debt(current US$) of Peru in 1971 to that in 1973?
Keep it short and to the point. 0.3. What is the ratio of the Debt(current US$) of Sudan in 1971 to that in 1973?
Your response must be concise. 0.16. What is the ratio of the Debt(current US$) in Jordan in 1971 to that in 1974?
Offer a very short reply. 1.77. What is the ratio of the Debt(current US$) of Lao PDR in 1971 to that in 1974?
Offer a very short reply. 0.72. What is the ratio of the Debt(current US$) of Peru in 1971 to that in 1974?
Offer a terse response. 0.3. What is the ratio of the Debt(current US$) of Sudan in 1971 to that in 1974?
Your answer should be very brief. 0.13. What is the ratio of the Debt(current US$) of Jordan in 1971 to that in 1975?
Offer a very short reply. 206.31. What is the ratio of the Debt(current US$) of Lao PDR in 1971 to that in 1975?
Offer a very short reply. 2.86. What is the ratio of the Debt(current US$) in Peru in 1971 to that in 1975?
Provide a short and direct response. 0.37. What is the ratio of the Debt(current US$) of Sudan in 1971 to that in 1975?
Your response must be concise. 0.1. What is the ratio of the Debt(current US$) of Jordan in 1971 to that in 1977?
Keep it short and to the point. 0.02. What is the ratio of the Debt(current US$) in Lao PDR in 1971 to that in 1977?
Provide a succinct answer. 3.33. What is the ratio of the Debt(current US$) in Peru in 1971 to that in 1977?
Your answer should be very brief. 0.23. What is the ratio of the Debt(current US$) in Sudan in 1971 to that in 1977?
Offer a very short reply. 0.1. What is the ratio of the Debt(current US$) of Jordan in 1972 to that in 1973?
Keep it short and to the point. 0.32. What is the ratio of the Debt(current US$) of Lao PDR in 1972 to that in 1973?
Your response must be concise. 0.9. What is the ratio of the Debt(current US$) in Peru in 1972 to that in 1973?
Offer a terse response. 0.47. What is the ratio of the Debt(current US$) of Sudan in 1972 to that in 1973?
Your answer should be very brief. 0.35. What is the ratio of the Debt(current US$) in Jordan in 1972 to that in 1974?
Offer a very short reply. 2.64. What is the ratio of the Debt(current US$) in Lao PDR in 1972 to that in 1974?
Keep it short and to the point. 1.33. What is the ratio of the Debt(current US$) of Peru in 1972 to that in 1974?
Provide a succinct answer. 0.47. What is the ratio of the Debt(current US$) in Sudan in 1972 to that in 1974?
Your answer should be very brief. 0.28. What is the ratio of the Debt(current US$) in Jordan in 1972 to that in 1975?
Your response must be concise. 306.38. What is the ratio of the Debt(current US$) in Lao PDR in 1972 to that in 1975?
Provide a short and direct response. 5.29. What is the ratio of the Debt(current US$) in Peru in 1972 to that in 1975?
Offer a terse response. 0.58. What is the ratio of the Debt(current US$) of Sudan in 1972 to that in 1975?
Give a very brief answer. 0.21. What is the ratio of the Debt(current US$) of Jordan in 1972 to that in 1977?
Provide a succinct answer. 0.03. What is the ratio of the Debt(current US$) of Lao PDR in 1972 to that in 1977?
Make the answer very short. 6.16. What is the ratio of the Debt(current US$) in Peru in 1972 to that in 1977?
Provide a succinct answer. 0.35. What is the ratio of the Debt(current US$) in Sudan in 1972 to that in 1977?
Your answer should be compact. 0.22. What is the ratio of the Debt(current US$) in Jordan in 1973 to that in 1974?
Make the answer very short. 8.36. What is the ratio of the Debt(current US$) of Lao PDR in 1973 to that in 1974?
Offer a terse response. 1.48. What is the ratio of the Debt(current US$) of Sudan in 1973 to that in 1974?
Your answer should be compact. 0.8. What is the ratio of the Debt(current US$) in Jordan in 1973 to that in 1975?
Provide a succinct answer. 972.08. What is the ratio of the Debt(current US$) of Lao PDR in 1973 to that in 1975?
Provide a short and direct response. 5.86. What is the ratio of the Debt(current US$) of Peru in 1973 to that in 1975?
Provide a succinct answer. 1.23. What is the ratio of the Debt(current US$) of Sudan in 1973 to that in 1975?
Your answer should be compact. 0.6. What is the ratio of the Debt(current US$) of Jordan in 1973 to that in 1977?
Give a very brief answer. 0.08. What is the ratio of the Debt(current US$) of Lao PDR in 1973 to that in 1977?
Give a very brief answer. 6.81. What is the ratio of the Debt(current US$) in Peru in 1973 to that in 1977?
Ensure brevity in your answer.  0.76. What is the ratio of the Debt(current US$) of Sudan in 1973 to that in 1977?
Your answer should be compact. 0.64. What is the ratio of the Debt(current US$) in Jordan in 1974 to that in 1975?
Offer a terse response. 116.23. What is the ratio of the Debt(current US$) in Lao PDR in 1974 to that in 1975?
Give a very brief answer. 3.97. What is the ratio of the Debt(current US$) in Peru in 1974 to that in 1975?
Your answer should be very brief. 1.24. What is the ratio of the Debt(current US$) in Sudan in 1974 to that in 1975?
Offer a terse response. 0.75. What is the ratio of the Debt(current US$) of Jordan in 1974 to that in 1977?
Offer a very short reply. 0.01. What is the ratio of the Debt(current US$) of Lao PDR in 1974 to that in 1977?
Your answer should be compact. 4.61. What is the ratio of the Debt(current US$) of Peru in 1974 to that in 1977?
Offer a very short reply. 0.76. What is the ratio of the Debt(current US$) of Sudan in 1974 to that in 1977?
Your answer should be very brief. 0.8. What is the ratio of the Debt(current US$) of Lao PDR in 1975 to that in 1977?
Your answer should be very brief. 1.16. What is the ratio of the Debt(current US$) in Peru in 1975 to that in 1977?
Keep it short and to the point. 0.62. What is the ratio of the Debt(current US$) of Sudan in 1975 to that in 1977?
Keep it short and to the point. 1.07. What is the difference between the highest and the second highest Debt(current US$) of Jordan?
Make the answer very short. 1.41e+08. What is the difference between the highest and the second highest Debt(current US$) in Lao PDR?
Give a very brief answer. 2.92e+05. What is the difference between the highest and the second highest Debt(current US$) of Peru?
Your response must be concise. 1.80e+08. What is the difference between the highest and the second highest Debt(current US$) of Sudan?
Ensure brevity in your answer.  1.09e+07. What is the difference between the highest and the lowest Debt(current US$) of Jordan?
Your answer should be compact. 1.54e+08. What is the difference between the highest and the lowest Debt(current US$) of Lao PDR?
Offer a very short reply. 2.59e+06. What is the difference between the highest and the lowest Debt(current US$) in Peru?
Offer a terse response. 6.84e+08. What is the difference between the highest and the lowest Debt(current US$) of Sudan?
Provide a succinct answer. 1.55e+08. 